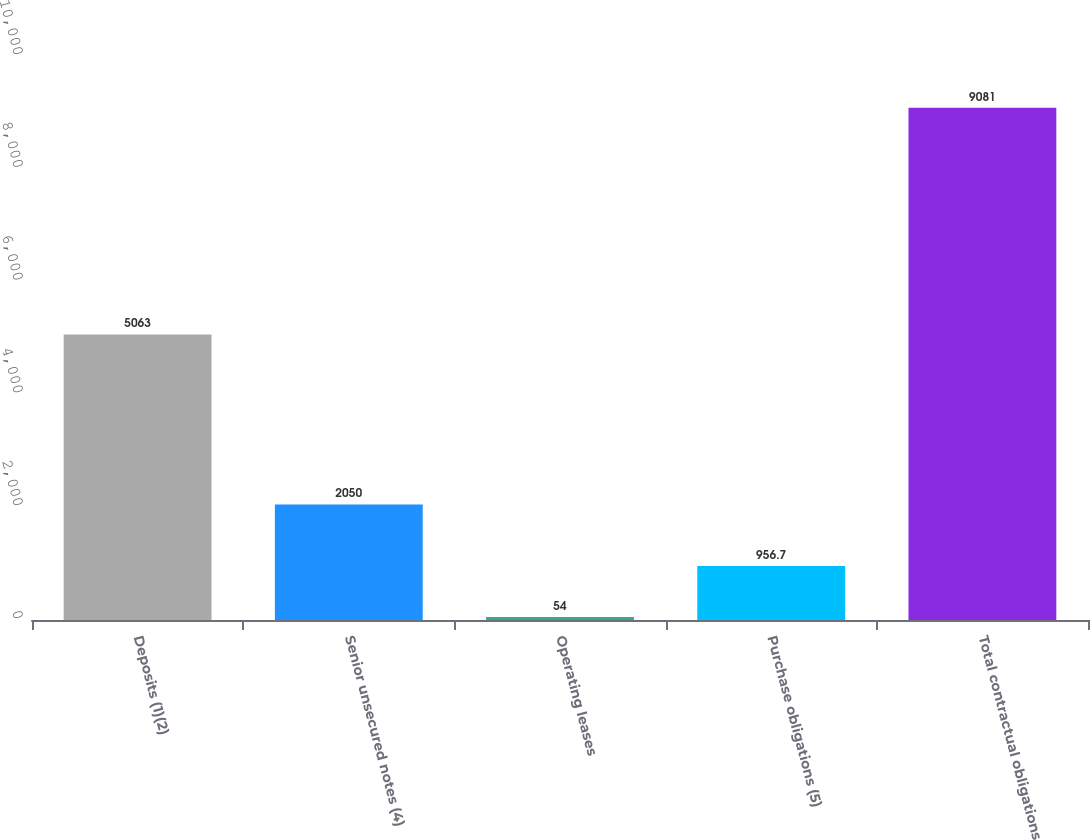Convert chart. <chart><loc_0><loc_0><loc_500><loc_500><bar_chart><fcel>Deposits (1)(2)<fcel>Senior unsecured notes (4)<fcel>Operating leases<fcel>Purchase obligations (5)<fcel>Total contractual obligations<nl><fcel>5063<fcel>2050<fcel>54<fcel>956.7<fcel>9081<nl></chart> 